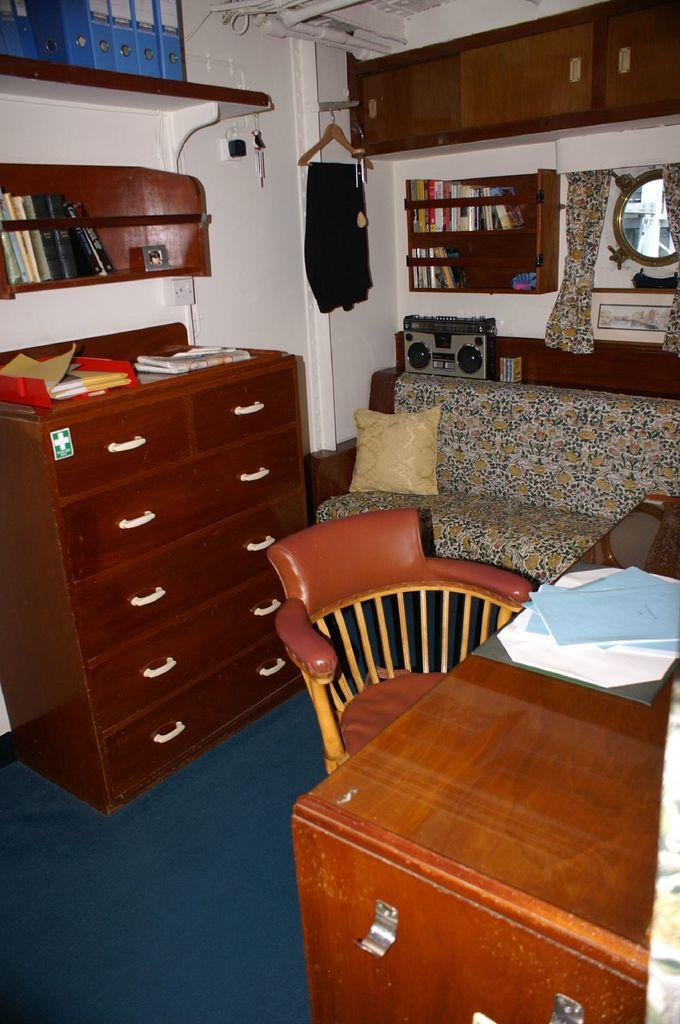What is the color of the wall in the image? The wall in the image is white. What type of furniture can be seen in the image? There is a sofa, a chair, and a table in the image. What objects are on the table in the image? There are papers and books on the table in the image. What other items can be found in the image? There is a cloth and a mirror in the image. What type of seed is growing near the coast in the image? There is no seed or coast present in the image; it features a room with furniture and objects. 